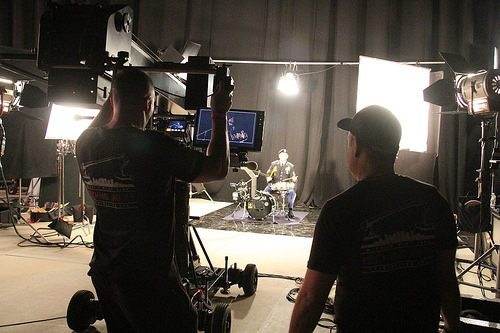<image>
Is there a screen to the left of the baseball cap? Yes. From this viewpoint, the screen is positioned to the left side relative to the baseball cap. 